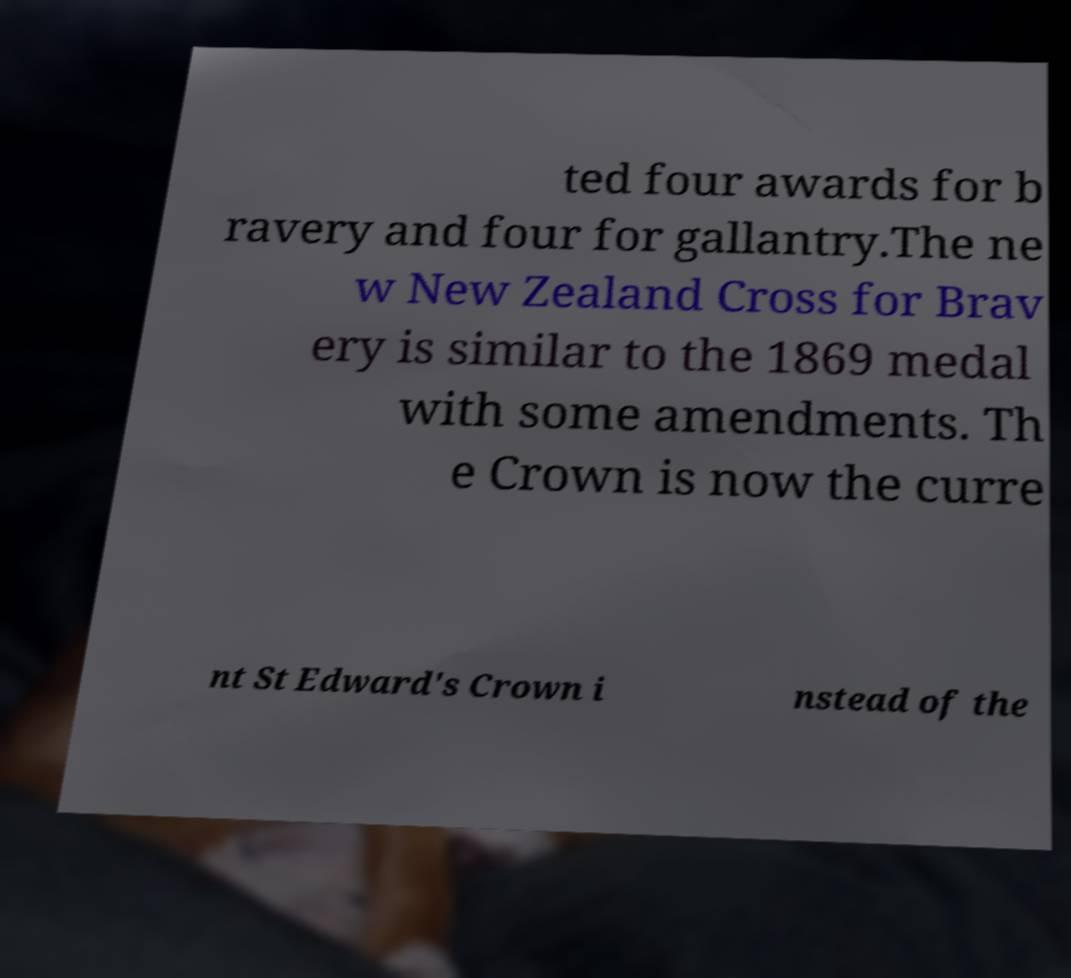Could you assist in decoding the text presented in this image and type it out clearly? ted four awards for b ravery and four for gallantry.The ne w New Zealand Cross for Brav ery is similar to the 1869 medal with some amendments. Th e Crown is now the curre nt St Edward's Crown i nstead of the 